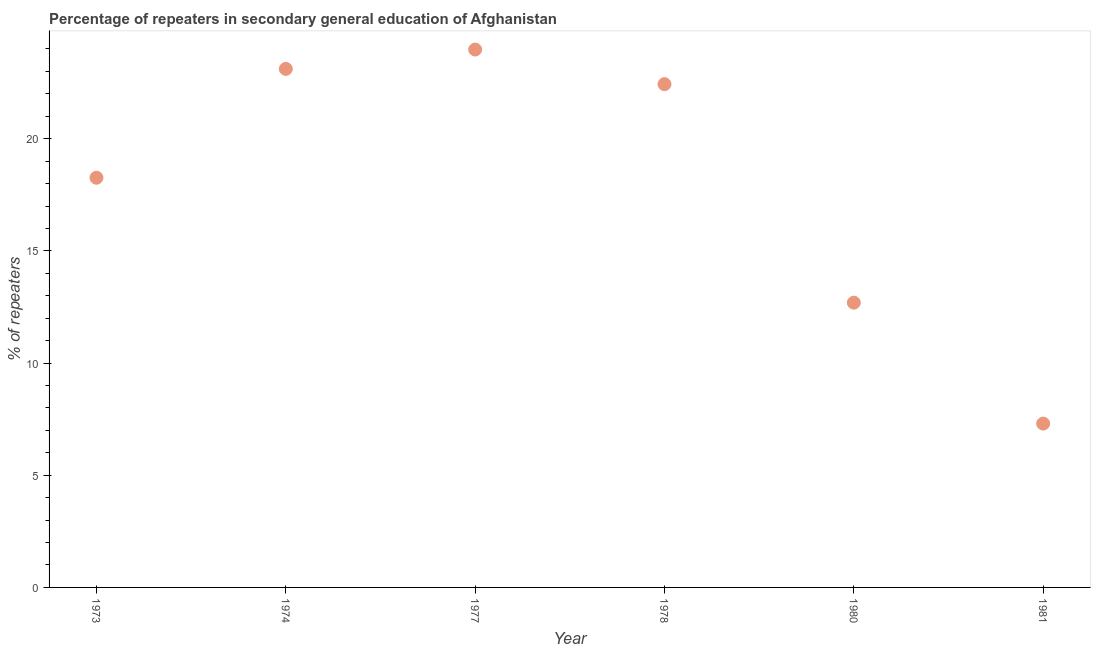What is the percentage of repeaters in 1981?
Keep it short and to the point. 7.3. Across all years, what is the maximum percentage of repeaters?
Keep it short and to the point. 23.97. Across all years, what is the minimum percentage of repeaters?
Make the answer very short. 7.3. In which year was the percentage of repeaters maximum?
Offer a very short reply. 1977. In which year was the percentage of repeaters minimum?
Ensure brevity in your answer.  1981. What is the sum of the percentage of repeaters?
Ensure brevity in your answer.  107.77. What is the difference between the percentage of repeaters in 1974 and 1978?
Your answer should be very brief. 0.68. What is the average percentage of repeaters per year?
Your answer should be very brief. 17.96. What is the median percentage of repeaters?
Make the answer very short. 20.35. What is the ratio of the percentage of repeaters in 1978 to that in 1980?
Offer a terse response. 1.77. Is the percentage of repeaters in 1980 less than that in 1981?
Make the answer very short. No. What is the difference between the highest and the second highest percentage of repeaters?
Provide a short and direct response. 0.86. Is the sum of the percentage of repeaters in 1973 and 1980 greater than the maximum percentage of repeaters across all years?
Give a very brief answer. Yes. What is the difference between the highest and the lowest percentage of repeaters?
Your response must be concise. 16.67. In how many years, is the percentage of repeaters greater than the average percentage of repeaters taken over all years?
Offer a very short reply. 4. Does the percentage of repeaters monotonically increase over the years?
Give a very brief answer. No. How many dotlines are there?
Provide a succinct answer. 1. Are the values on the major ticks of Y-axis written in scientific E-notation?
Provide a short and direct response. No. Does the graph contain grids?
Offer a terse response. No. What is the title of the graph?
Provide a short and direct response. Percentage of repeaters in secondary general education of Afghanistan. What is the label or title of the Y-axis?
Offer a very short reply. % of repeaters. What is the % of repeaters in 1973?
Your answer should be compact. 18.26. What is the % of repeaters in 1974?
Offer a terse response. 23.11. What is the % of repeaters in 1977?
Your answer should be very brief. 23.97. What is the % of repeaters in 1978?
Keep it short and to the point. 22.43. What is the % of repeaters in 1980?
Your response must be concise. 12.69. What is the % of repeaters in 1981?
Offer a terse response. 7.3. What is the difference between the % of repeaters in 1973 and 1974?
Your answer should be compact. -4.85. What is the difference between the % of repeaters in 1973 and 1977?
Offer a terse response. -5.72. What is the difference between the % of repeaters in 1973 and 1978?
Provide a succinct answer. -4.17. What is the difference between the % of repeaters in 1973 and 1980?
Offer a terse response. 5.57. What is the difference between the % of repeaters in 1973 and 1981?
Make the answer very short. 10.96. What is the difference between the % of repeaters in 1974 and 1977?
Ensure brevity in your answer.  -0.86. What is the difference between the % of repeaters in 1974 and 1978?
Offer a very short reply. 0.68. What is the difference between the % of repeaters in 1974 and 1980?
Your answer should be compact. 10.42. What is the difference between the % of repeaters in 1974 and 1981?
Ensure brevity in your answer.  15.81. What is the difference between the % of repeaters in 1977 and 1978?
Make the answer very short. 1.54. What is the difference between the % of repeaters in 1977 and 1980?
Your answer should be very brief. 11.28. What is the difference between the % of repeaters in 1977 and 1981?
Give a very brief answer. 16.67. What is the difference between the % of repeaters in 1978 and 1980?
Your answer should be very brief. 9.74. What is the difference between the % of repeaters in 1978 and 1981?
Keep it short and to the point. 15.13. What is the difference between the % of repeaters in 1980 and 1981?
Make the answer very short. 5.39. What is the ratio of the % of repeaters in 1973 to that in 1974?
Ensure brevity in your answer.  0.79. What is the ratio of the % of repeaters in 1973 to that in 1977?
Your answer should be compact. 0.76. What is the ratio of the % of repeaters in 1973 to that in 1978?
Offer a terse response. 0.81. What is the ratio of the % of repeaters in 1973 to that in 1980?
Provide a short and direct response. 1.44. What is the ratio of the % of repeaters in 1974 to that in 1977?
Keep it short and to the point. 0.96. What is the ratio of the % of repeaters in 1974 to that in 1980?
Keep it short and to the point. 1.82. What is the ratio of the % of repeaters in 1974 to that in 1981?
Give a very brief answer. 3.17. What is the ratio of the % of repeaters in 1977 to that in 1978?
Provide a short and direct response. 1.07. What is the ratio of the % of repeaters in 1977 to that in 1980?
Provide a succinct answer. 1.89. What is the ratio of the % of repeaters in 1977 to that in 1981?
Your answer should be compact. 3.28. What is the ratio of the % of repeaters in 1978 to that in 1980?
Make the answer very short. 1.77. What is the ratio of the % of repeaters in 1978 to that in 1981?
Your answer should be very brief. 3.07. What is the ratio of the % of repeaters in 1980 to that in 1981?
Ensure brevity in your answer.  1.74. 